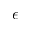<formula> <loc_0><loc_0><loc_500><loc_500>\epsilon</formula> 